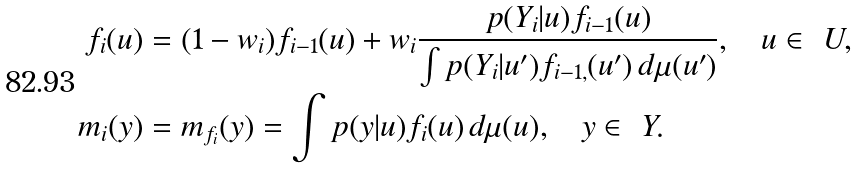<formula> <loc_0><loc_0><loc_500><loc_500>f _ { i } ( u ) & = ( 1 - w _ { i } ) f _ { i - 1 } ( u ) + w _ { i } \frac { p ( Y _ { i } | u ) f _ { i - 1 } ( u ) } { \int p ( Y _ { i } | u ^ { \prime } ) f _ { i - 1 , } ( u ^ { \prime } ) \, d \mu ( u ^ { \prime } ) } , \quad u \in \ U , \\ m _ { i } ( y ) & = m _ { f _ { i } } ( y ) = \int p ( y | u ) f _ { i } ( u ) \, d \mu ( u ) , \quad y \in \ Y .</formula> 